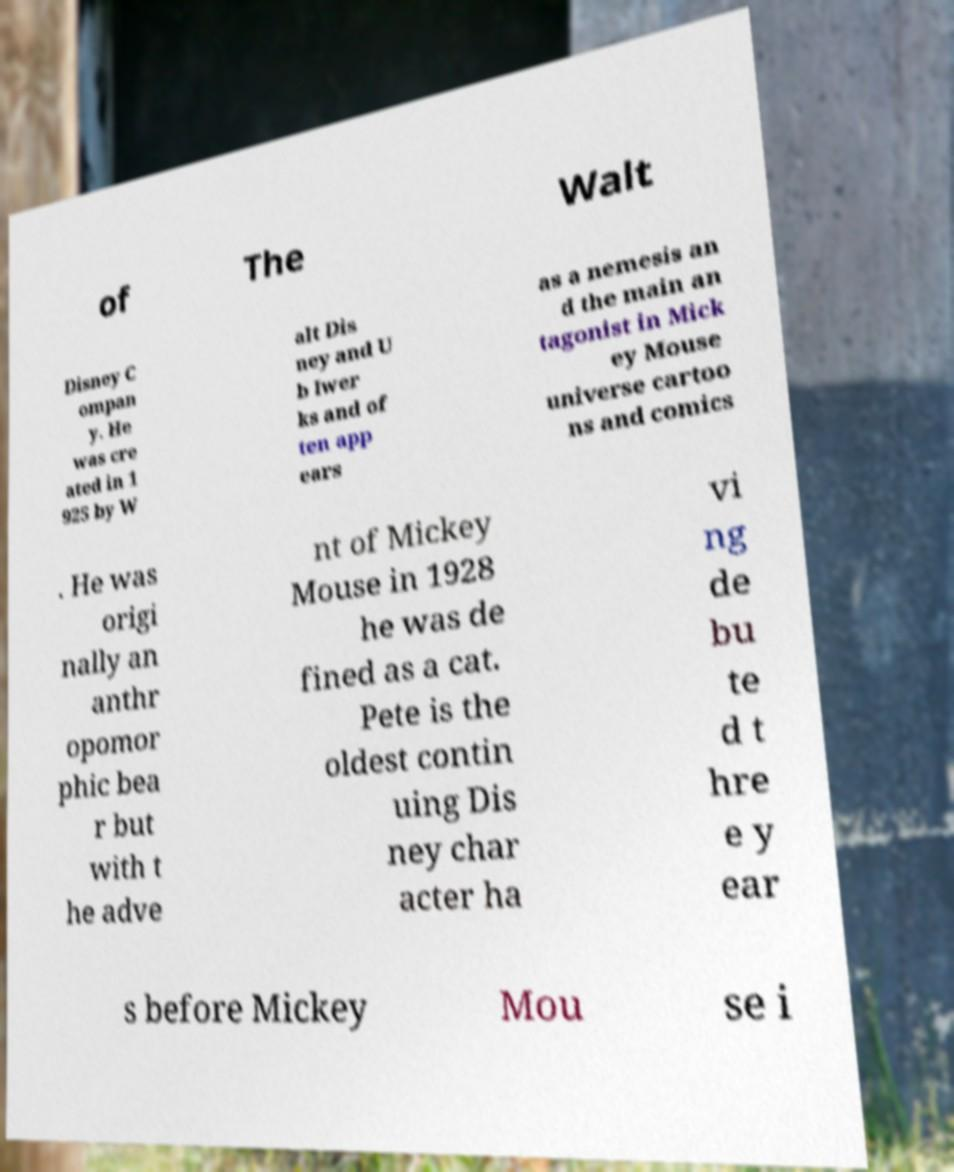For documentation purposes, I need the text within this image transcribed. Could you provide that? of The Walt Disney C ompan y. He was cre ated in 1 925 by W alt Dis ney and U b Iwer ks and of ten app ears as a nemesis an d the main an tagonist in Mick ey Mouse universe cartoo ns and comics . He was origi nally an anthr opomor phic bea r but with t he adve nt of Mickey Mouse in 1928 he was de fined as a cat. Pete is the oldest contin uing Dis ney char acter ha vi ng de bu te d t hre e y ear s before Mickey Mou se i 